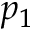Convert formula to latex. <formula><loc_0><loc_0><loc_500><loc_500>p _ { 1 }</formula> 